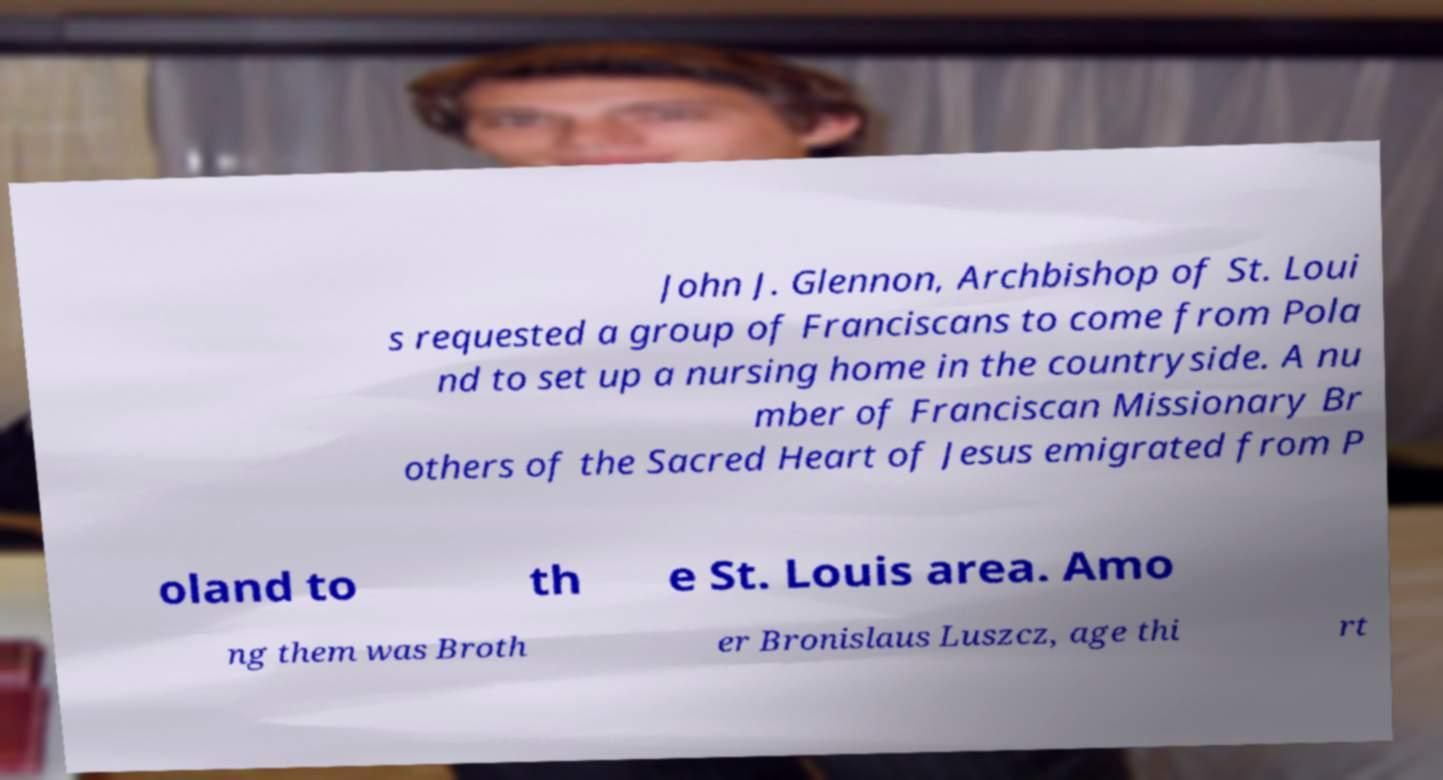There's text embedded in this image that I need extracted. Can you transcribe it verbatim? John J. Glennon, Archbishop of St. Loui s requested a group of Franciscans to come from Pola nd to set up a nursing home in the countryside. A nu mber of Franciscan Missionary Br others of the Sacred Heart of Jesus emigrated from P oland to th e St. Louis area. Amo ng them was Broth er Bronislaus Luszcz, age thi rt 